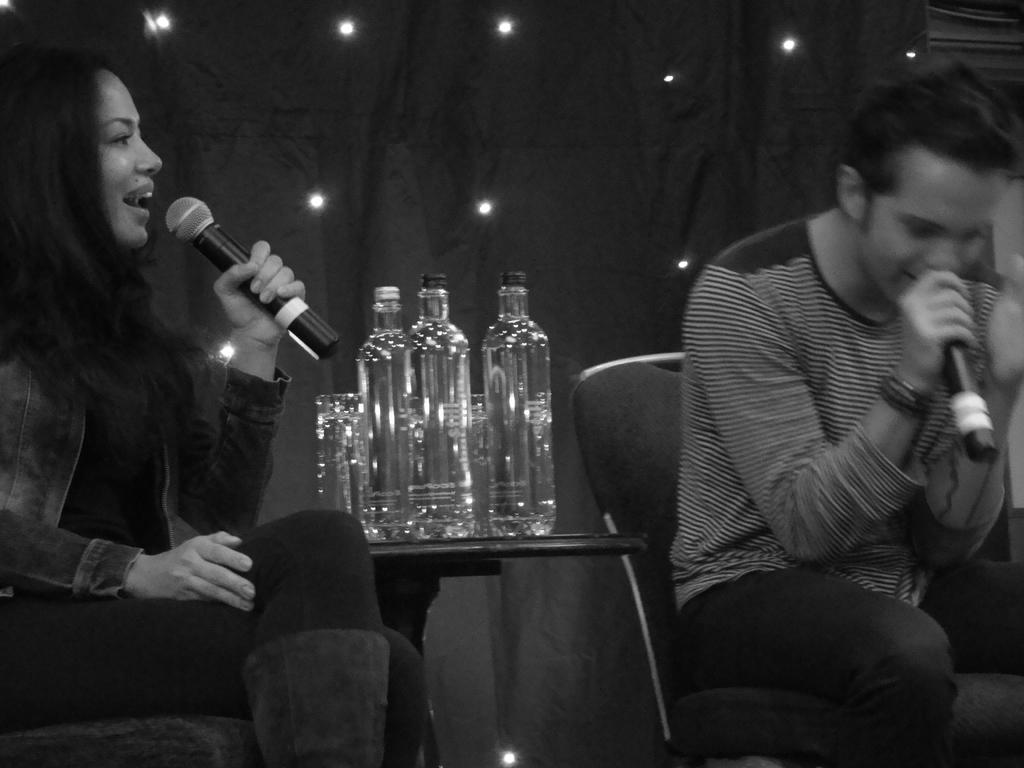Who can be seen in the image? There is a woman and a man in the image. What are they holding? Both the woman and man are holding microphones. What are their positions in the image? They are sitting on chairs. What is between the chairs? There is a table between the chairs. What is on the table? There are bottles on the table. What type of shade is being used to protect the microphones from sunlight in the image? There is no shade present in the image, and the microphones are not being protected from sunlight. 